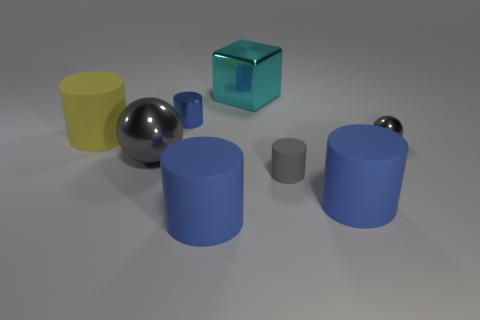Is the number of matte things greater than the number of large cyan shiny objects?
Provide a succinct answer. Yes. What number of cyan blocks are there?
Your answer should be compact. 1. What shape is the large blue matte object to the left of the tiny gray rubber cylinder that is to the right of the blue cylinder behind the big yellow object?
Your response must be concise. Cylinder. Is the number of big matte cylinders right of the large cyan object less than the number of big cyan things in front of the gray matte cylinder?
Make the answer very short. No. There is a large metal object behind the small blue cylinder; is it the same shape as the large blue matte thing that is left of the metal block?
Your response must be concise. No. The metal thing behind the cylinder that is behind the large yellow matte cylinder is what shape?
Provide a short and direct response. Cube. The other metal ball that is the same color as the big sphere is what size?
Ensure brevity in your answer.  Small. Are there any cylinders that have the same material as the tiny sphere?
Your answer should be compact. Yes. What is the gray object that is on the right side of the small gray matte object made of?
Keep it short and to the point. Metal. What is the material of the big yellow cylinder?
Your answer should be compact. Rubber. 